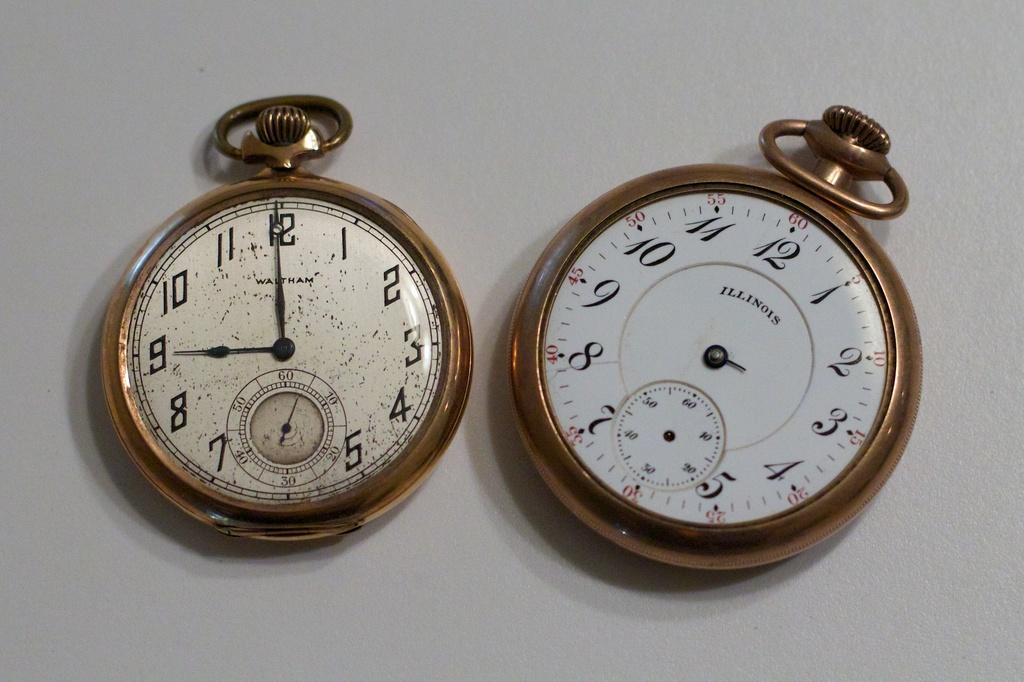<image>
Summarize the visual content of the image. gold and white pocket watches made by Illinois 